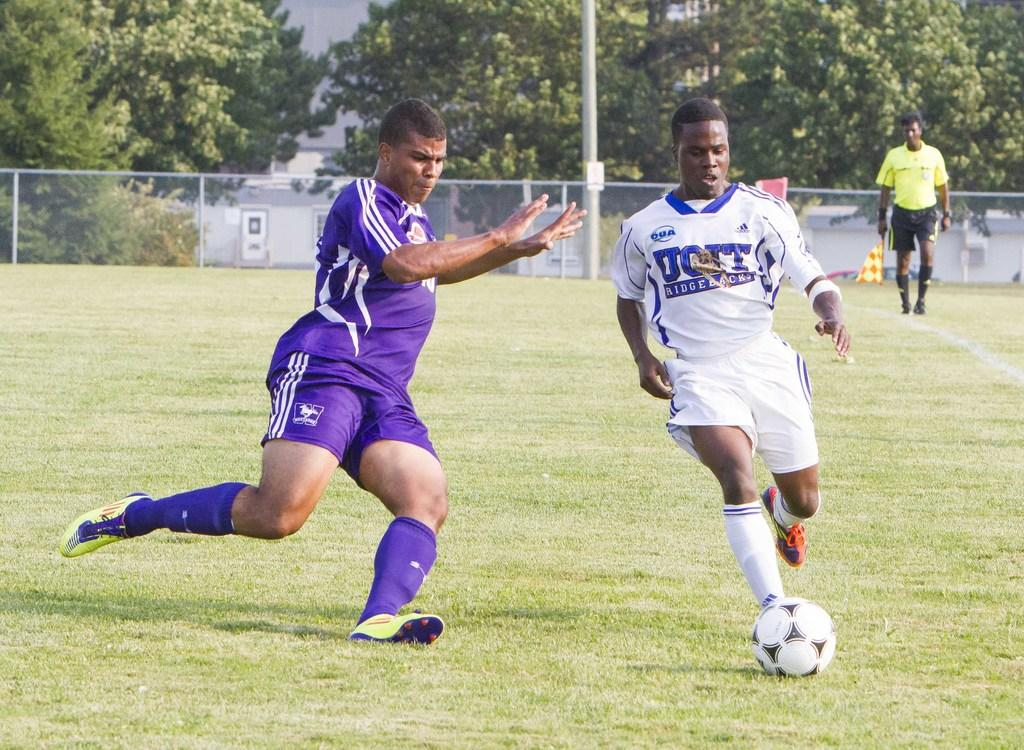What are the two persons in the image doing? The two persons in the image are running. What is in front of one of the running persons? There is a ball in front of one of the running persons. What is the third person doing in the image? The third person is walking far away from the running persons. Can you describe the leg movement of the walking person? Yes, there is leg movement visible for the walking person. What can be seen in the background of the image? Trees are present in the background of the image. What type of music can be heard playing from the jail in the image? There is no jail present in the image, and therefore no music can be heard from it. 